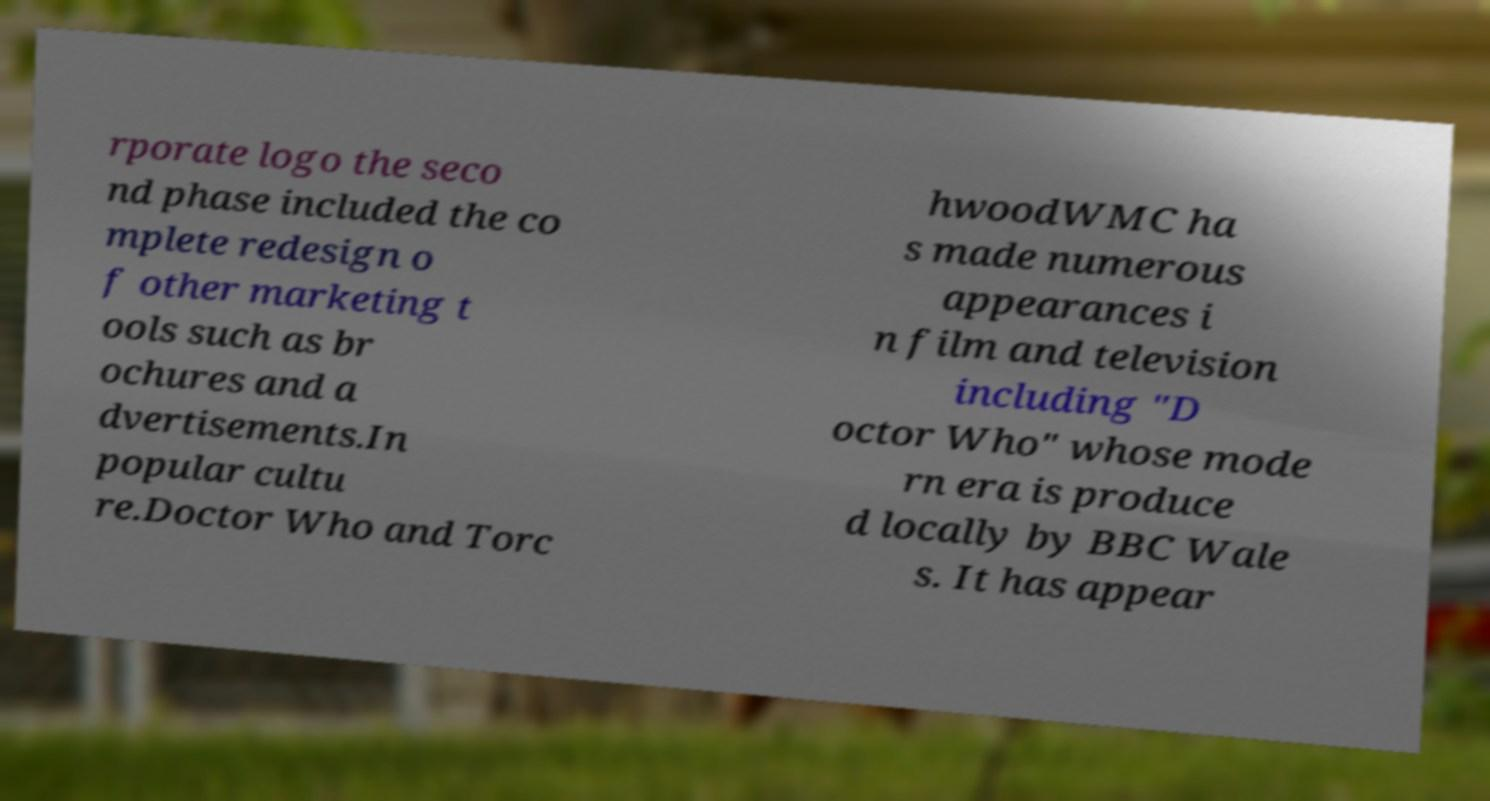What messages or text are displayed in this image? I need them in a readable, typed format. rporate logo the seco nd phase included the co mplete redesign o f other marketing t ools such as br ochures and a dvertisements.In popular cultu re.Doctor Who and Torc hwoodWMC ha s made numerous appearances i n film and television including "D octor Who" whose mode rn era is produce d locally by BBC Wale s. It has appear 